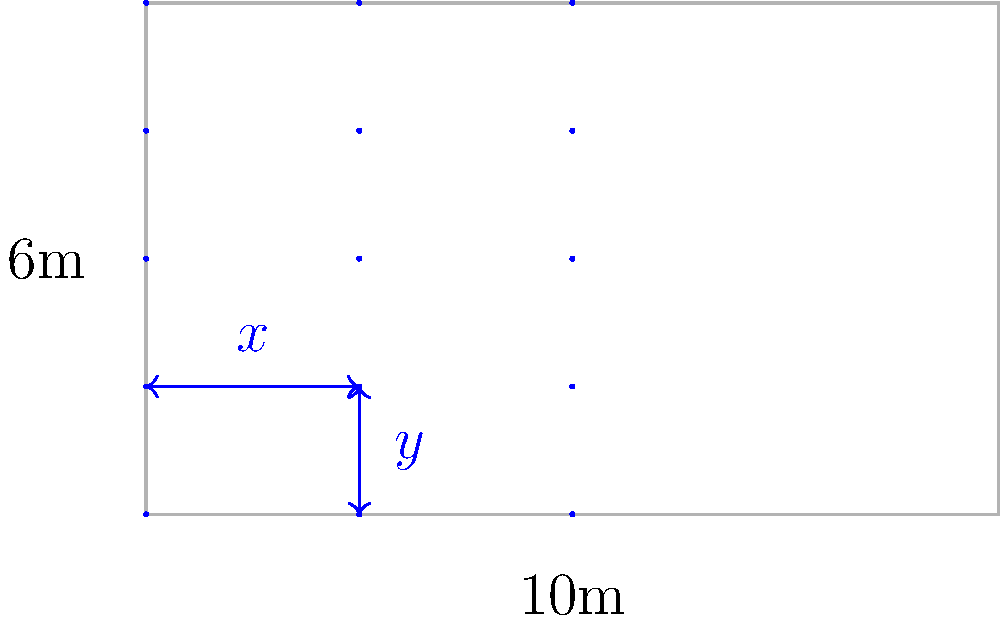A dance performance involves 15 dancers arranged in a rectangular grid formation on a 10m × 6m stage. The choreographer wants to maximize the space between dancers while ensuring equal spacing. If the dancers are positioned in 3 rows and 5 columns, what is the optimal spacing between adjacent dancers in both horizontal ($x$) and vertical ($y$) directions? Let's approach this step-by-step:

1) The stage dimensions are 10m × 6m.

2) The dancers are arranged in 3 rows and 5 columns.

3) For horizontal spacing ($x$):
   - There are 5 columns, which means 4 spaces between them
   - The total width is 10m
   - Equation: $4x + 5d = 10$, where $d$ is the diameter of space occupied by a dancer
   
4) For vertical spacing ($y$):
   - There are 3 rows, which means 2 spaces between them
   - The total height is 6m
   - Equation: $2y + 3d = 6$

5) We want to maximize space, so we assume dancers occupy minimal space. Let's say $d ≈ 0$.

6) Now our equations simplify to:
   - $4x = 10$
   - $2y = 6$

7) Solving these:
   - $x = 10 ÷ 4 = 2.5$m
   - $y = 6 ÷ 2 = 3$m

Therefore, the optimal spacing is 2.5m horizontally and 3m vertically.
Answer: $x = 2.5$m, $y = 3$m 